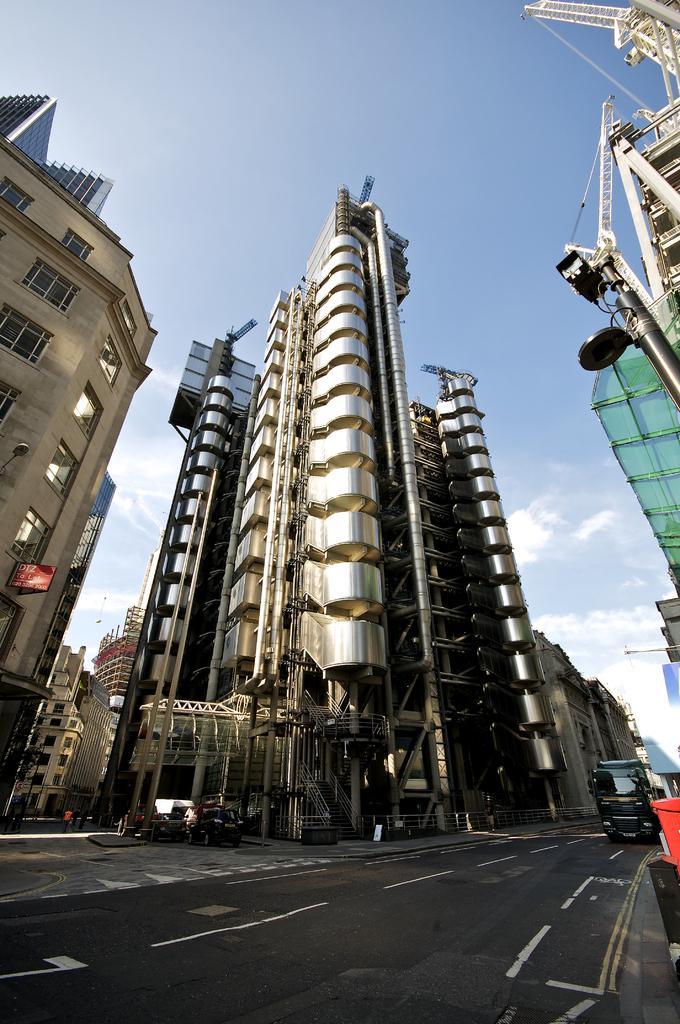Can you describe this image briefly? In this image we can see buildings, motor vehicles, iron grills and sky with clouds. 